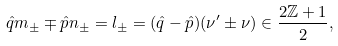Convert formula to latex. <formula><loc_0><loc_0><loc_500><loc_500>\hat { q } m _ { \pm } \mp \hat { p } n _ { \pm } = l _ { \pm } = ( \hat { q } - \hat { p } ) ( \nu ^ { \prime } \pm \nu ) \in \frac { 2 \mathbb { Z } + 1 } { 2 } ,</formula> 